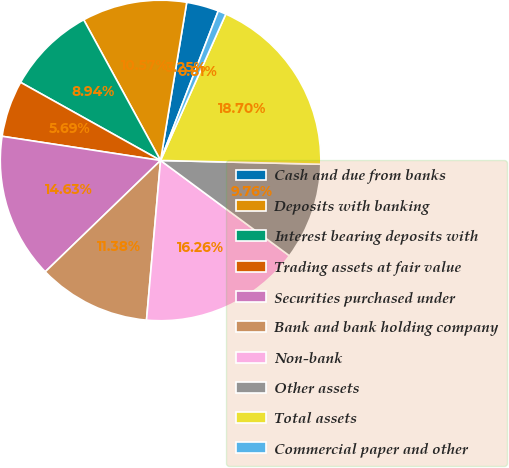Convert chart. <chart><loc_0><loc_0><loc_500><loc_500><pie_chart><fcel>Cash and due from banks<fcel>Deposits with banking<fcel>Interest bearing deposits with<fcel>Trading assets at fair value<fcel>Securities purchased under<fcel>Bank and bank holding company<fcel>Non-bank<fcel>Other assets<fcel>Total assets<fcel>Commercial paper and other<nl><fcel>3.25%<fcel>10.57%<fcel>8.94%<fcel>5.69%<fcel>14.63%<fcel>11.38%<fcel>16.26%<fcel>9.76%<fcel>18.7%<fcel>0.81%<nl></chart> 